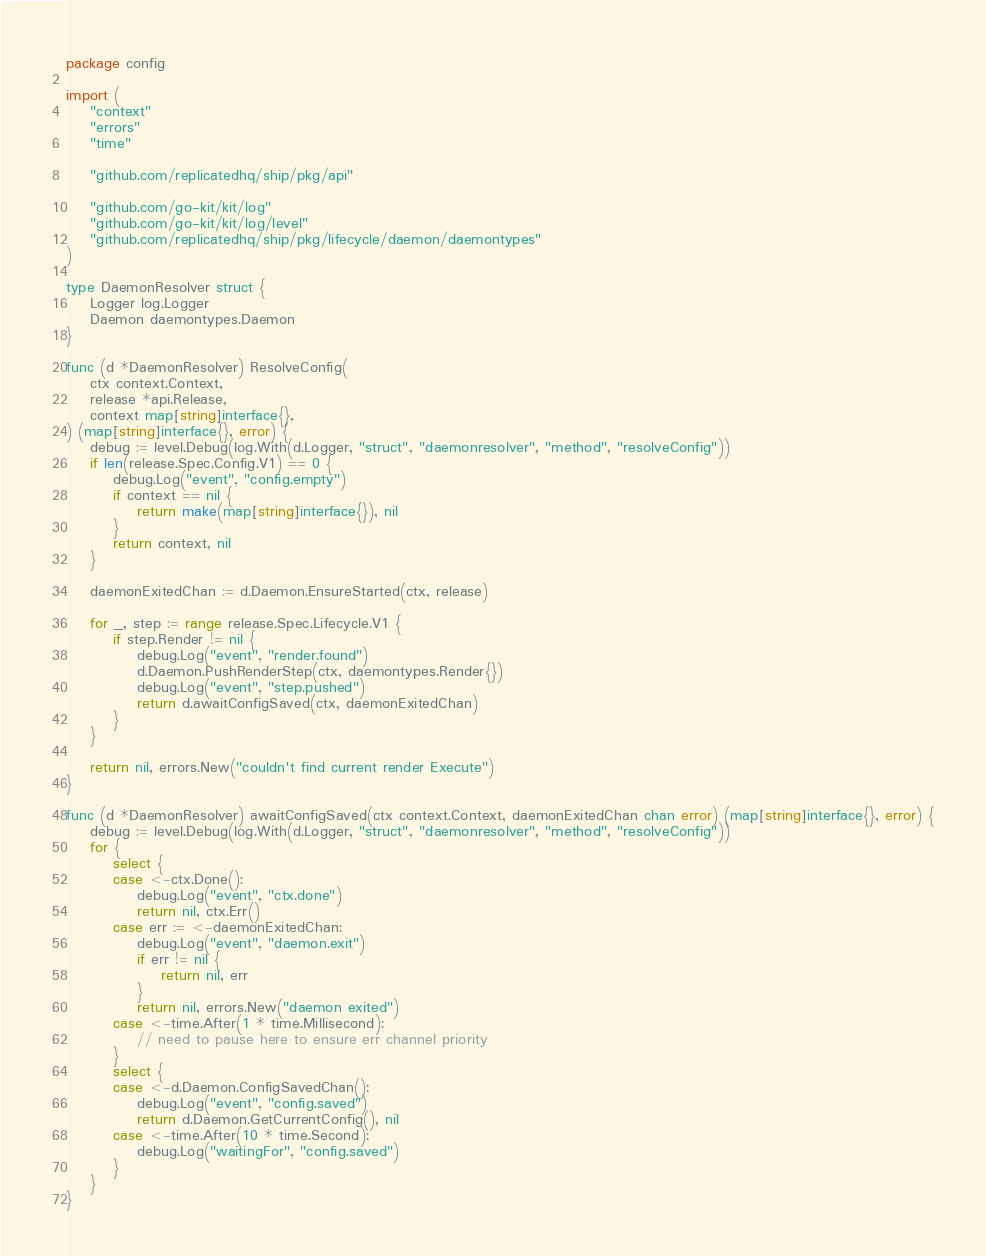Convert code to text. <code><loc_0><loc_0><loc_500><loc_500><_Go_>package config

import (
	"context"
	"errors"
	"time"

	"github.com/replicatedhq/ship/pkg/api"

	"github.com/go-kit/kit/log"
	"github.com/go-kit/kit/log/level"
	"github.com/replicatedhq/ship/pkg/lifecycle/daemon/daemontypes"
)

type DaemonResolver struct {
	Logger log.Logger
	Daemon daemontypes.Daemon
}

func (d *DaemonResolver) ResolveConfig(
	ctx context.Context,
	release *api.Release,
	context map[string]interface{},
) (map[string]interface{}, error) {
	debug := level.Debug(log.With(d.Logger, "struct", "daemonresolver", "method", "resolveConfig"))
	if len(release.Spec.Config.V1) == 0 {
		debug.Log("event", "config.empty")
		if context == nil {
			return make(map[string]interface{}), nil
		}
		return context, nil
	}

	daemonExitedChan := d.Daemon.EnsureStarted(ctx, release)

	for _, step := range release.Spec.Lifecycle.V1 {
		if step.Render != nil {
			debug.Log("event", "render.found")
			d.Daemon.PushRenderStep(ctx, daemontypes.Render{})
			debug.Log("event", "step.pushed")
			return d.awaitConfigSaved(ctx, daemonExitedChan)
		}
	}

	return nil, errors.New("couldn't find current render Execute")
}

func (d *DaemonResolver) awaitConfigSaved(ctx context.Context, daemonExitedChan chan error) (map[string]interface{}, error) {
	debug := level.Debug(log.With(d.Logger, "struct", "daemonresolver", "method", "resolveConfig"))
	for {
		select {
		case <-ctx.Done():
			debug.Log("event", "ctx.done")
			return nil, ctx.Err()
		case err := <-daemonExitedChan:
			debug.Log("event", "daemon.exit")
			if err != nil {
				return nil, err
			}
			return nil, errors.New("daemon exited")
		case <-time.After(1 * time.Millisecond):
			// need to pause here to ensure err channel priority
		}
		select {
		case <-d.Daemon.ConfigSavedChan():
			debug.Log("event", "config.saved")
			return d.Daemon.GetCurrentConfig(), nil
		case <-time.After(10 * time.Second):
			debug.Log("waitingFor", "config.saved")
		}
	}
}
</code> 